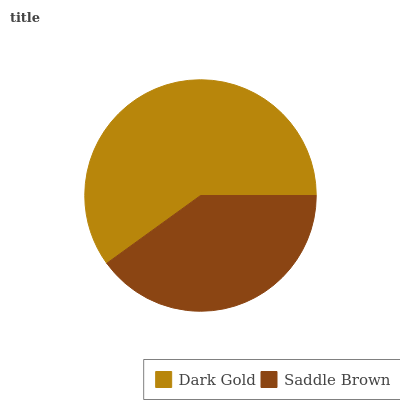Is Saddle Brown the minimum?
Answer yes or no. Yes. Is Dark Gold the maximum?
Answer yes or no. Yes. Is Saddle Brown the maximum?
Answer yes or no. No. Is Dark Gold greater than Saddle Brown?
Answer yes or no. Yes. Is Saddle Brown less than Dark Gold?
Answer yes or no. Yes. Is Saddle Brown greater than Dark Gold?
Answer yes or no. No. Is Dark Gold less than Saddle Brown?
Answer yes or no. No. Is Dark Gold the high median?
Answer yes or no. Yes. Is Saddle Brown the low median?
Answer yes or no. Yes. Is Saddle Brown the high median?
Answer yes or no. No. Is Dark Gold the low median?
Answer yes or no. No. 